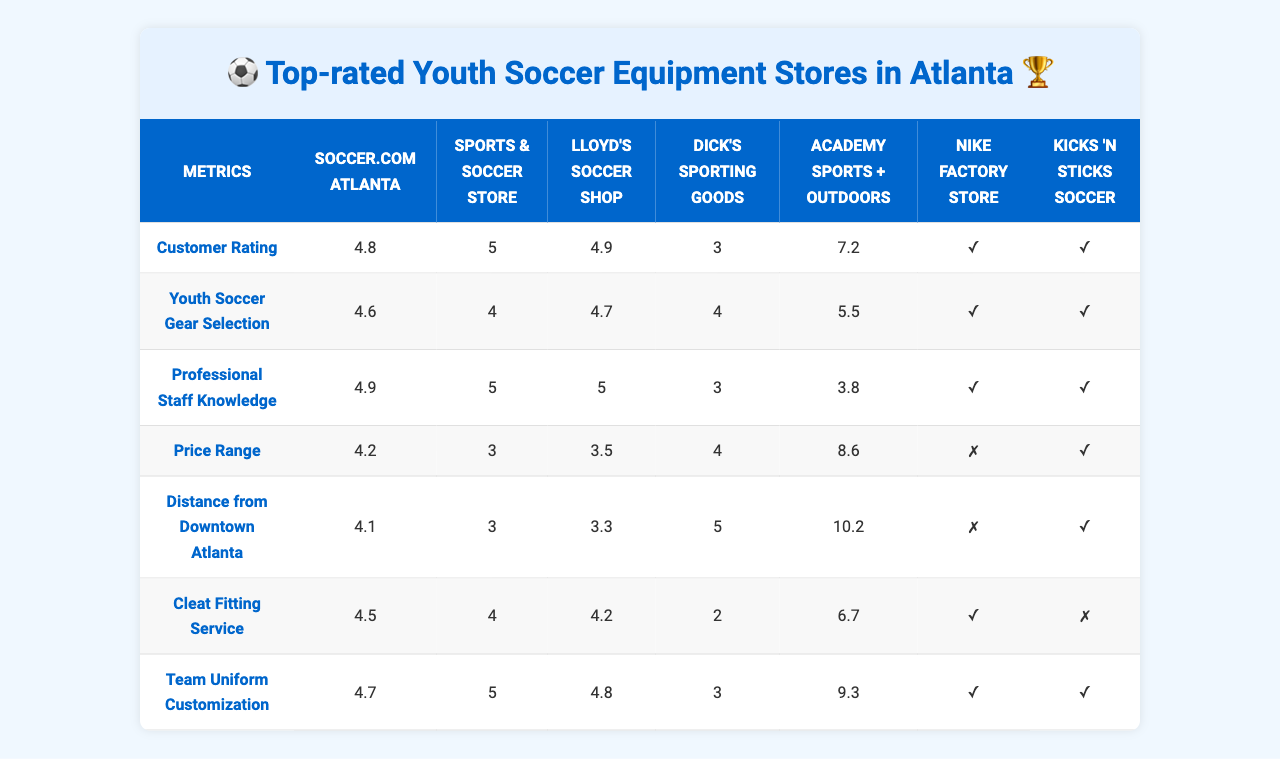What is the customer rating of Soccer.com Atlanta? The table shows that Soccer.com Atlanta has a customer rating of 4.8.
Answer: 4.8 Which store has the best selection of youth soccer gear? The table indicates that Soccer.com Atlanta and Lloyd's Soccer Shop both have a selection rating of 5, which is the highest among all stores listed.
Answer: Soccer.com Atlanta and Lloyd's Soccer Shop Does Dick's Sporting Goods offer a Cleat Fitting Service? The table shows that Dick's Sporting Goods has a rating of 0 for Cleat Fitting Service, indicating that they do not offer this service.
Answer: No What is the price range rating for Academy Sports + Outdoors? Academy Sports + Outdoors has a price range rating of 5 according to the table.
Answer: 5 Which store is closest to Downtown Atlanta? According to the table, Lloyd's Soccer Shop is the closest to Downtown Atlanta with a distance of 3.8 miles.
Answer: Lloyd's Soccer Shop What is the average customer rating of the stores? To calculate the average customer rating, sum the ratings (4.8 + 4.6 + 4.9 + 4.2 + 4.1 + 4.5 + 4.7) which equals 28.8. Then, divide by the number of stores (28.8 / 7) = 4.114285714, approximately 4.11.
Answer: 4.11 Which store has both Cleat Fitting Service and Team Uniform Customization? By examining the table, Kicks 'N Sticks Soccer, Soccer.com Atlanta, Sports & Soccer Store, and Lloyd's Soccer Shop offer both services as they have a rating of 1 (yes) in both categories.
Answer: Kicks 'N Sticks Soccer, Soccer.com Atlanta, Sports & Soccer Store, and Lloyd's Soccer Shop Is the distance from Downtown Atlanta to Nike Factory Store greater than 7 miles? According to the table, the distance to Nike Factory Store is 6.7 miles, which is less than 7 miles.
Answer: No Which store has the highest rating for Professional Staff Knowledge? The table shows that Lloyd's Soccer Shop has the highest rating for Professional Staff Knowledge at 5.
Answer: Lloyd's Soccer Shop What is the difference in distance from Downtown Atlanta between the furthest and closest stores? The furthest store is Academy Sports + Outdoors at 10.2 miles and the closest is Lloyd's Soccer Shop at 3.8 miles. The difference is 10.2 - 3.8 = 6.4 miles.
Answer: 6.4 miles 